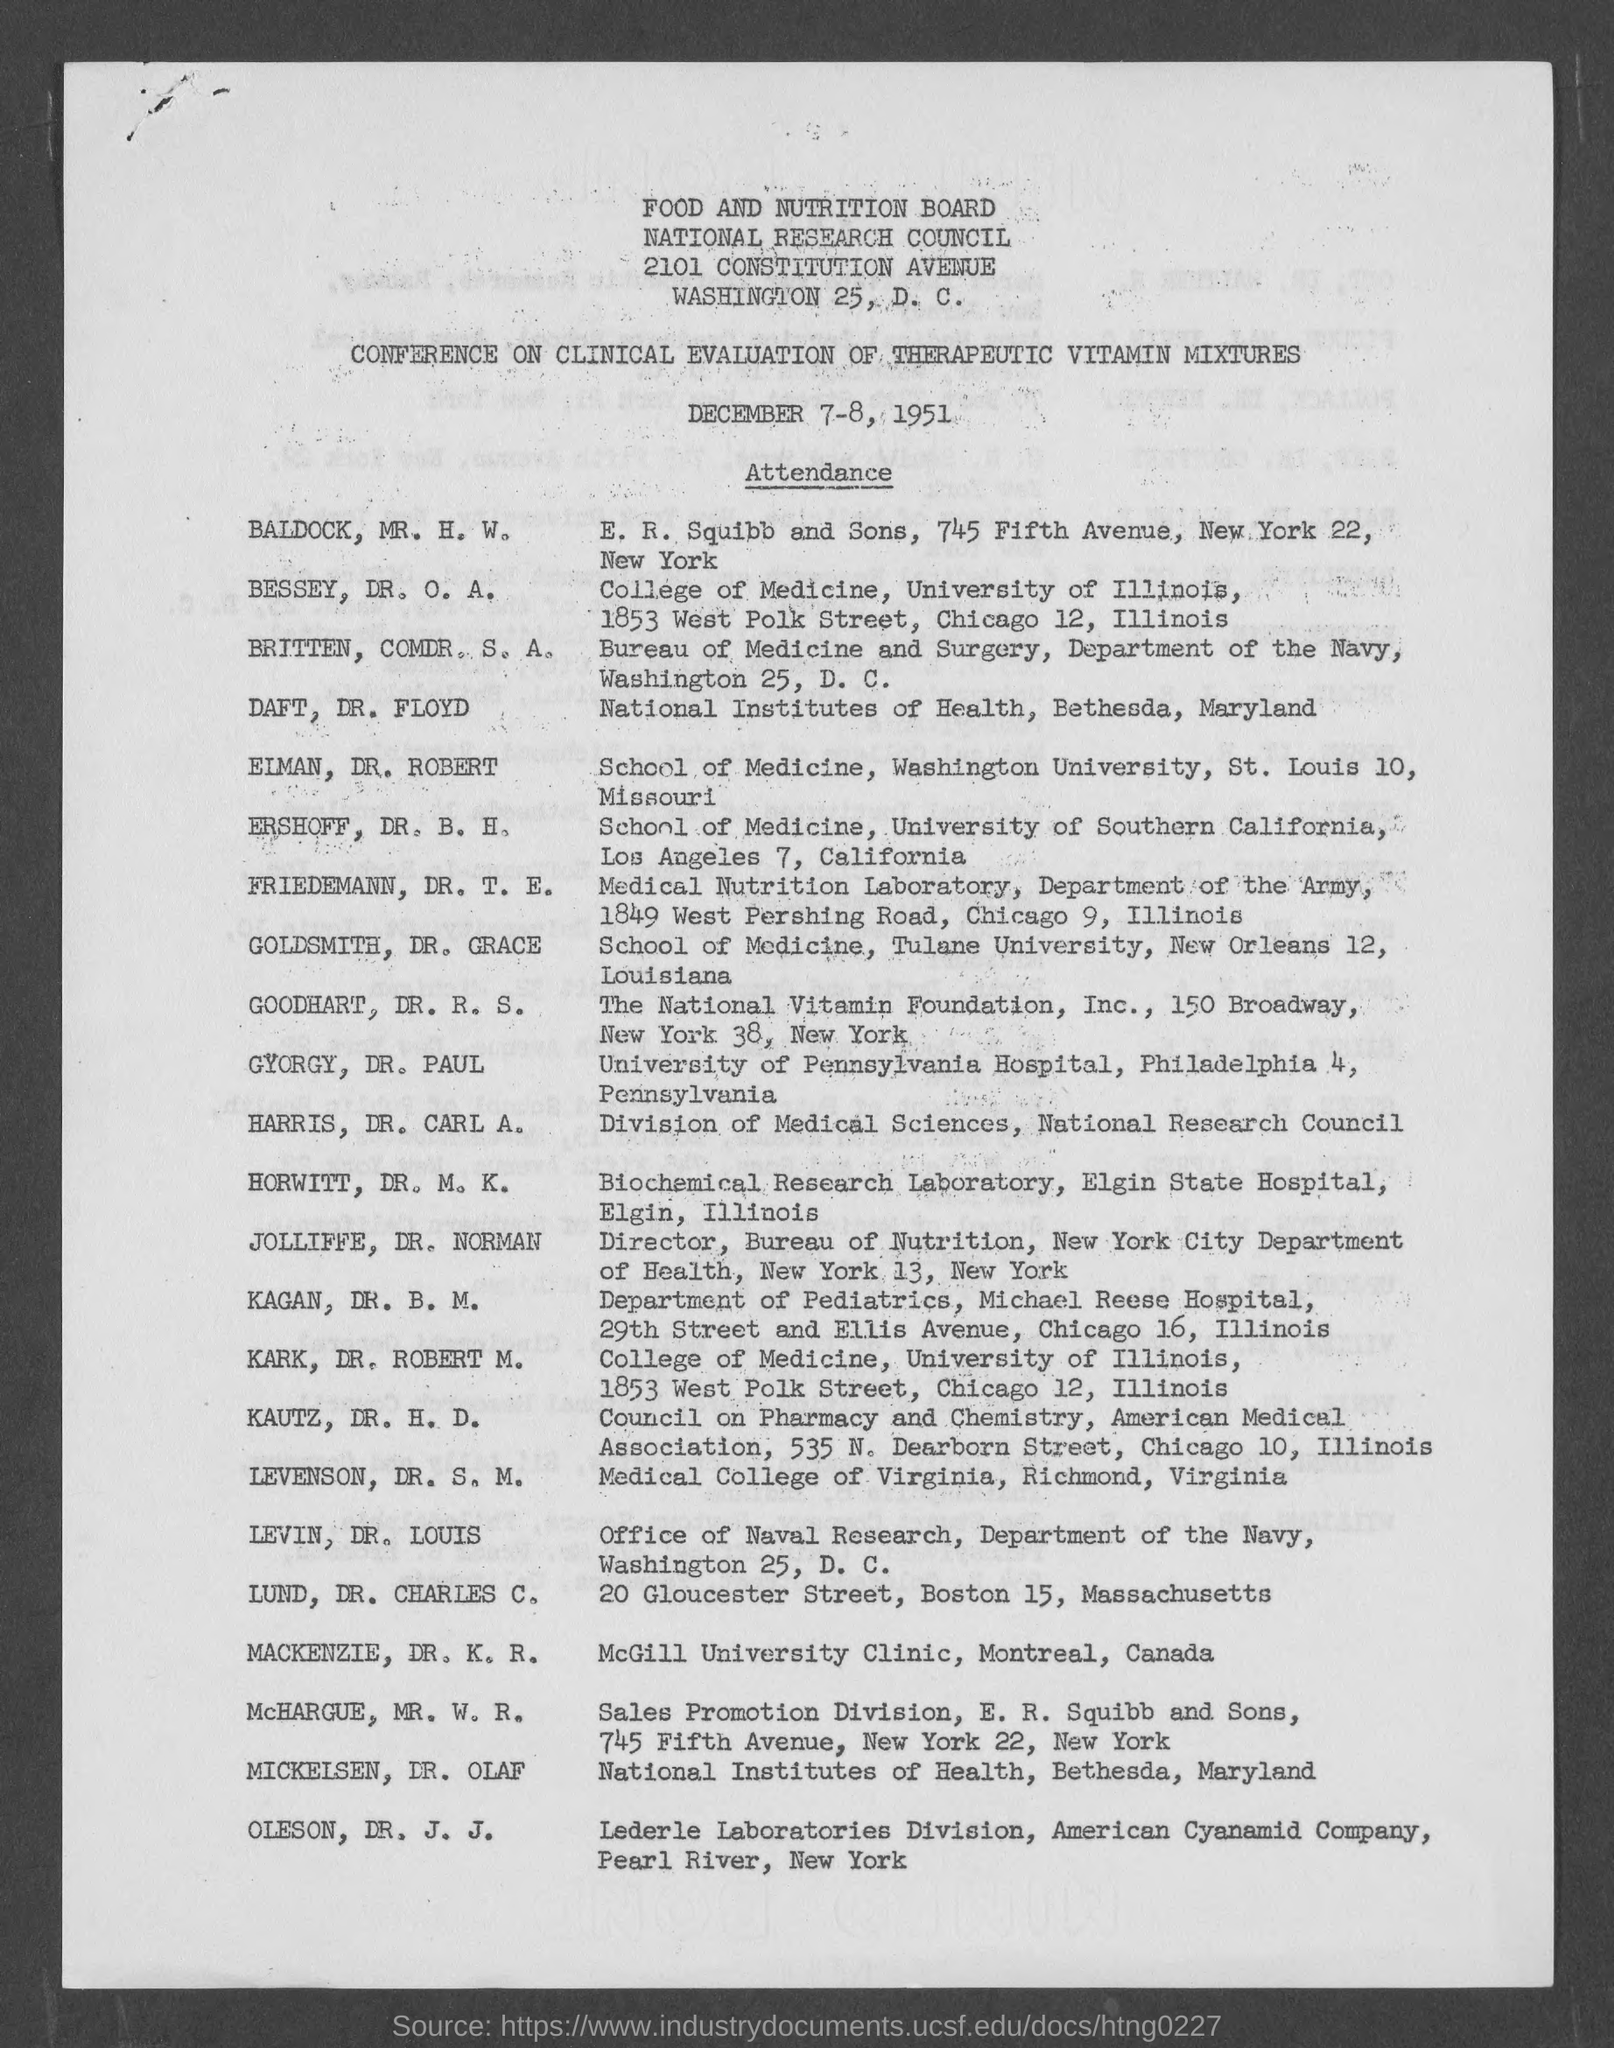When is the conference going to be held?
Offer a very short reply. DECEMBER 7-8, 1951. Which board is mentioned?
Your answer should be very brief. FOOD AND NUTRITION BOARD. Which council is mentioned?
Provide a short and direct response. National Research Council. 